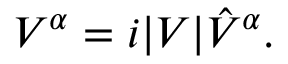Convert formula to latex. <formula><loc_0><loc_0><loc_500><loc_500>V ^ { \alpha } = i | V | \hat { V } ^ { \alpha } .</formula> 